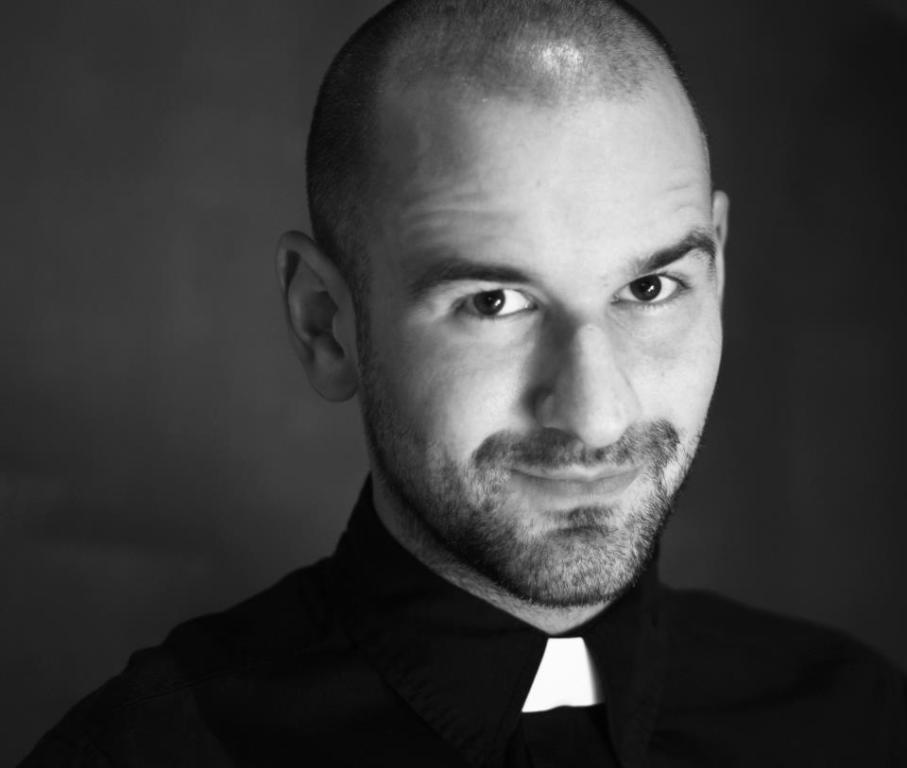What is the color scheme of the image? The image is black and white. Can you describe the main subject of the image? There is a person in the image. What type of meat is being served to the person's brothers in the image? There is no meat or brothers present in the image; it only features a person in a black and white setting. 